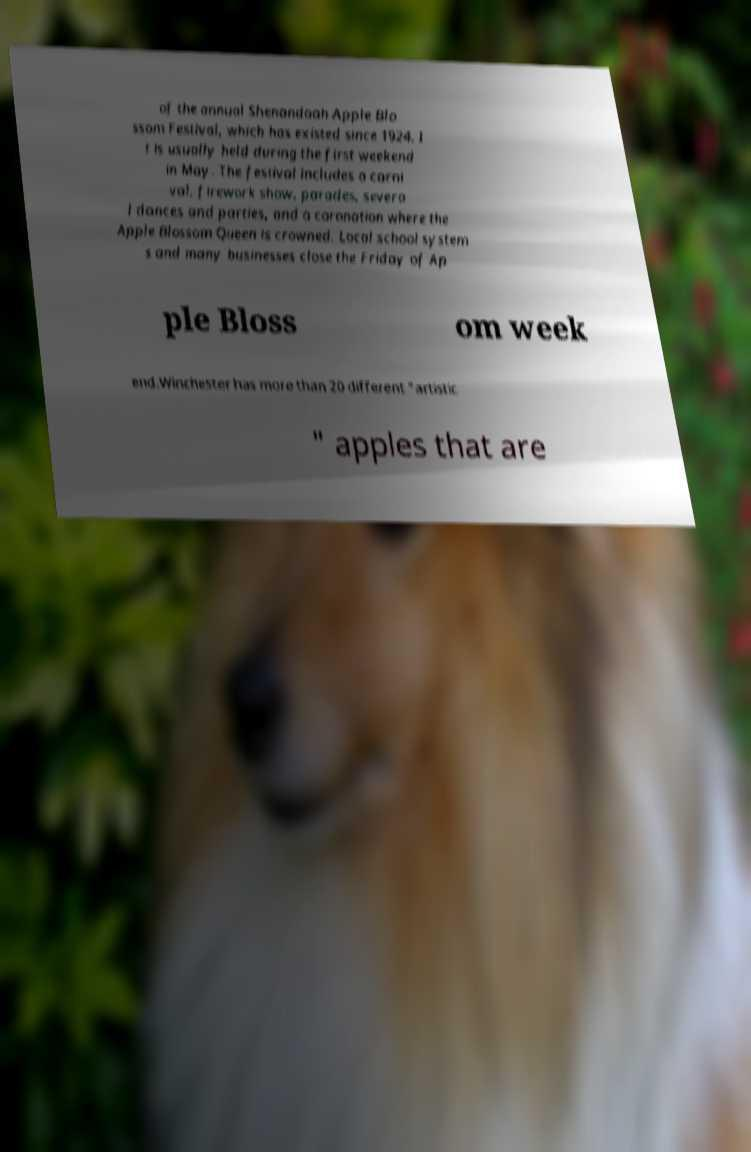What messages or text are displayed in this image? I need them in a readable, typed format. of the annual Shenandoah Apple Blo ssom Festival, which has existed since 1924. I t is usually held during the first weekend in May. The festival includes a carni val, firework show, parades, severa l dances and parties, and a coronation where the Apple Blossom Queen is crowned. Local school system s and many businesses close the Friday of Ap ple Bloss om week end.Winchester has more than 20 different "artistic " apples that are 